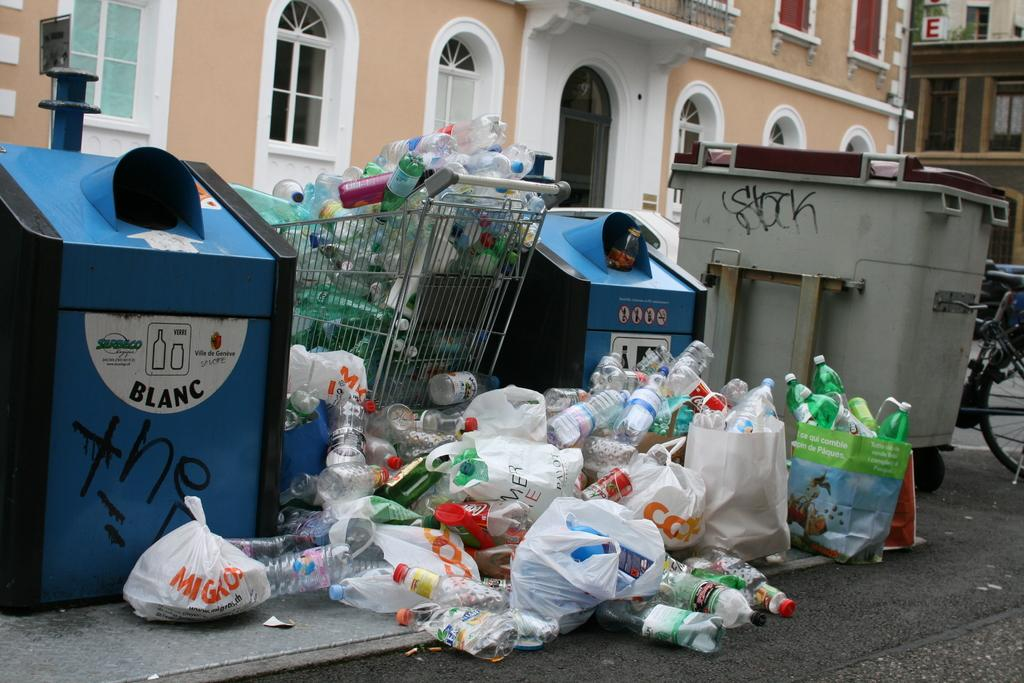<image>
Share a concise interpretation of the image provided. Several trash cans on a street and one has the word blanc on it. 